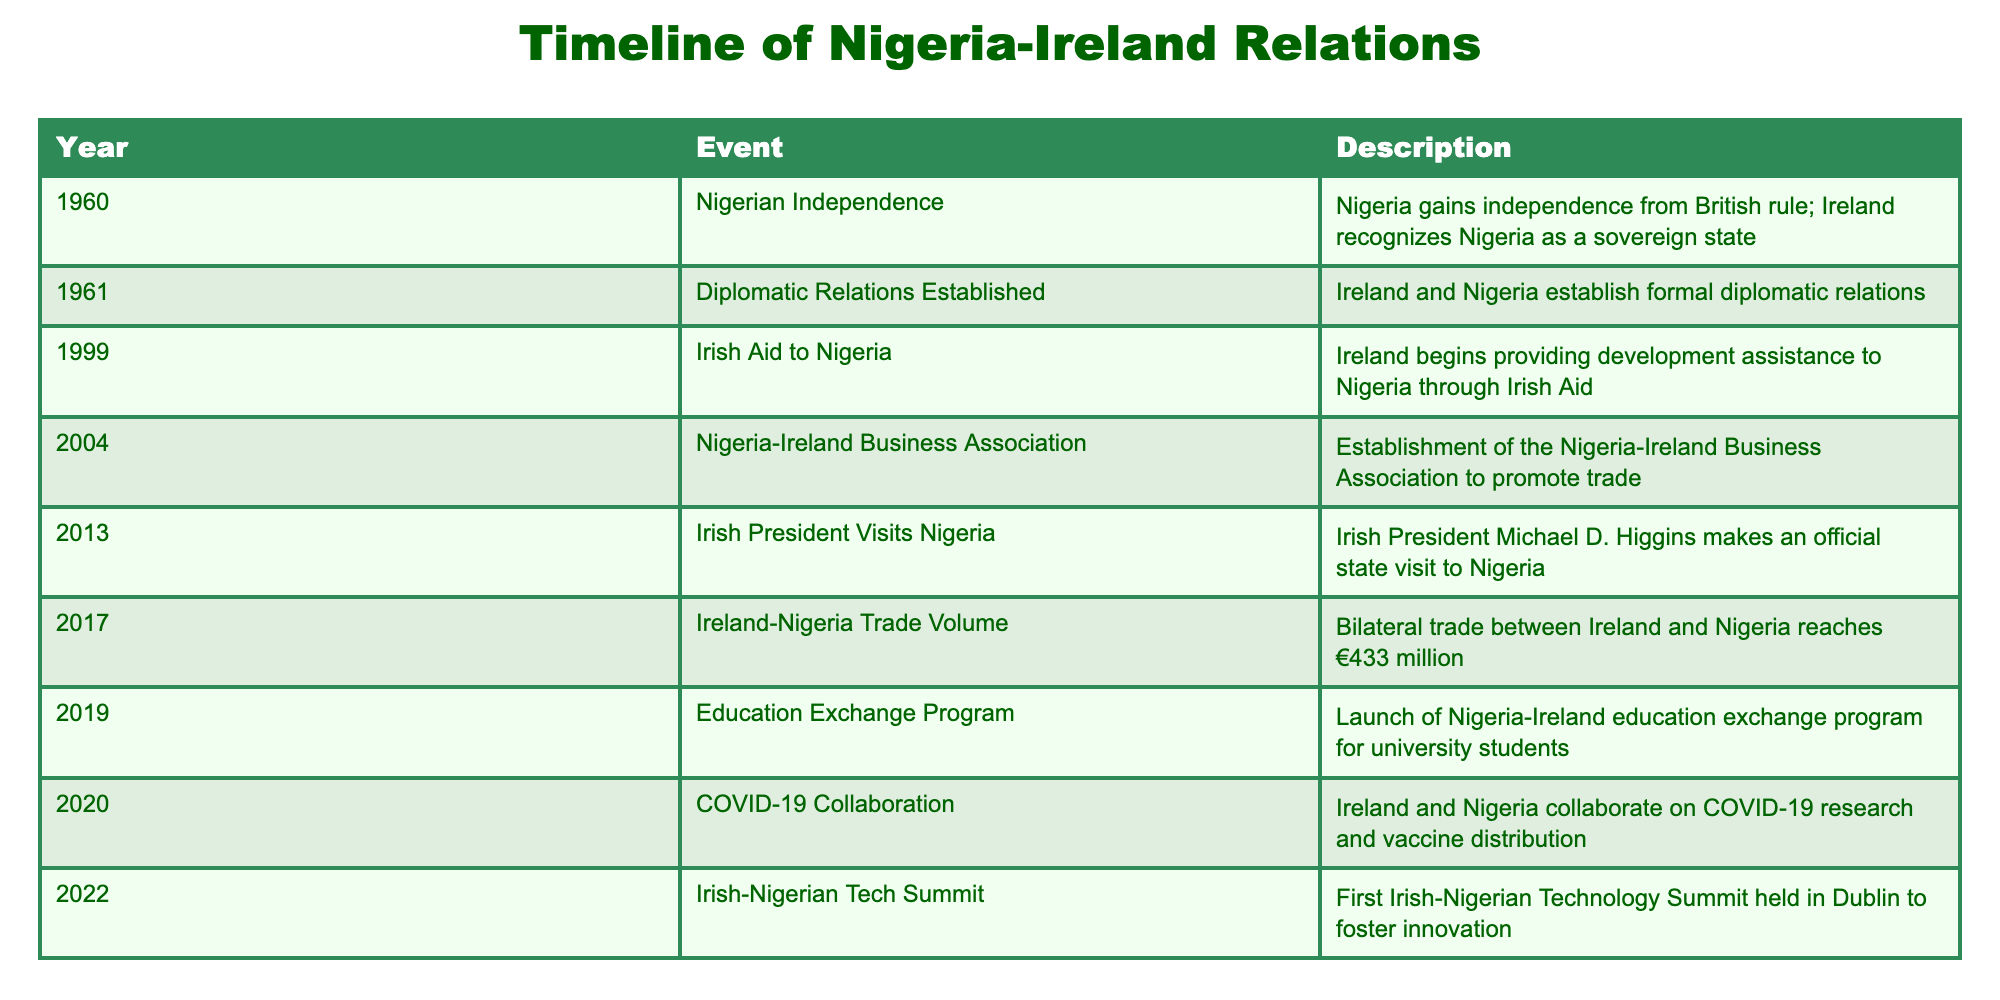What year did Nigeria gain independence? The table lists the events chronologically by year. The event "Nigerian Independence" corresponds to the year 1960.
Answer: 1960 When was the Nigeria-Ireland Business Association established? Referring to the timeline, the establishment of the Nigeria-Ireland Business Association is recorded in the year 2004.
Answer: 2004 What is the total number of significant events listed in the timeline? Counting the events from the table, there are 9 distinct events listed: one for each year from 1960 to 2022.
Answer: 9 Did Ireland provide aid to Nigeria before the 21st century? The table shows that Irish Aid to Nigeria began in 1999, which is the first mention of aid in the timeline. Thus, it stands to reason that no aid was provided before then.
Answer: No Which event marks the first official visit of an Irish President to Nigeria? Scanning the table, the entry for "Irish President Visits Nigeria" in 2013 indicates it was the first official visit by an Irish President to Nigeria.
Answer: 2013 What was the trade volume between Ireland and Nigeria in 2017, and how does it compare to the previous years? According to the table, the trade volume reached €433 million in 2017. There are no preceding years listed with trade volume figures, so we can only note that this is a significant milestone without prior context.
Answer: €433 million What type of collaboration occurred in 2020, and what issue did it address? The table specifies "COVID-19 Collaboration" in 2020, showing that the focus of the collaboration was on COVID-19 research and vaccine distribution.
Answer: COVID-19 research and vaccine distribution How many years passed between the establishment of diplomatic relations and the launch of the education exchange program? The diplomatic relations were established in 1961 and the education exchange program was launched in 2019. The difference in years is 2019 - 1961 = 58 years.
Answer: 58 years What cultural event took place in 2022? The table lists the "Irish-Nigerian Tech Summit" as the event held in 2022, highlighting the focus on technology and innovation.
Answer: Irish-Nigerian Tech Summit 